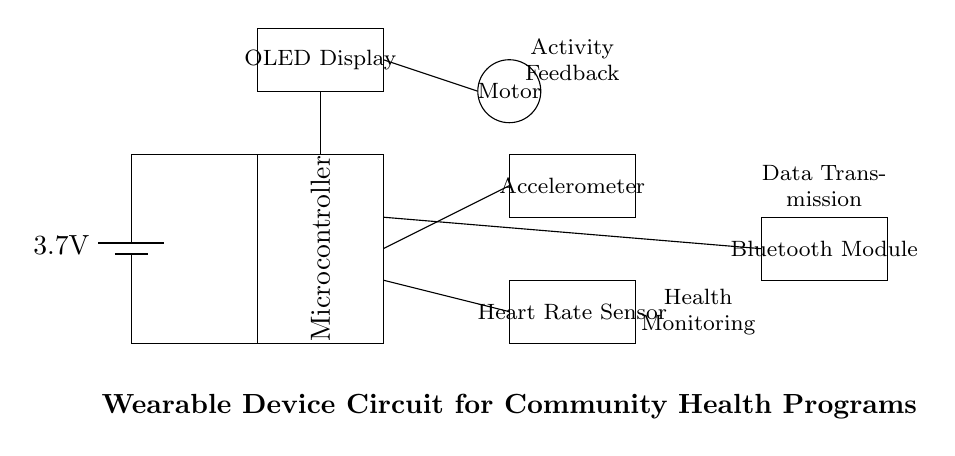What is the voltage of this circuit? The voltage is 3.7V, which is indicated by the battery symbol in the circuit diagram.
Answer: 3.7V What components are used for sensing health data? The components used for sensing health data are the accelerometer and the heart rate sensor, which are labeled in the diagram.
Answer: Accelerometer, Heart Rate Sensor What is the purpose of the Bluetooth module in this design? The Bluetooth module is used for data transmission, allowing the wearable device to send collected health data to other devices or applications.
Answer: Data Transmission How does the device provide feedback to the user? The device provides feedback through the OLED display and the vibration motor, which are both connected to the microcontroller for activity feedback.
Answer: Activity Feedback What is the relationship between the microcontroller and the sensors? The microcontroller processes the data from the accelerometer and heart rate sensor, enabling it to monitor health metrics and interact with other components of the device.
Answer: Data Processing Which component is responsible for the physical response to activity? The component responsible for the physical response to activity is the vibration motor, which activates to signal the user based on activity levels.
Answer: Motor 